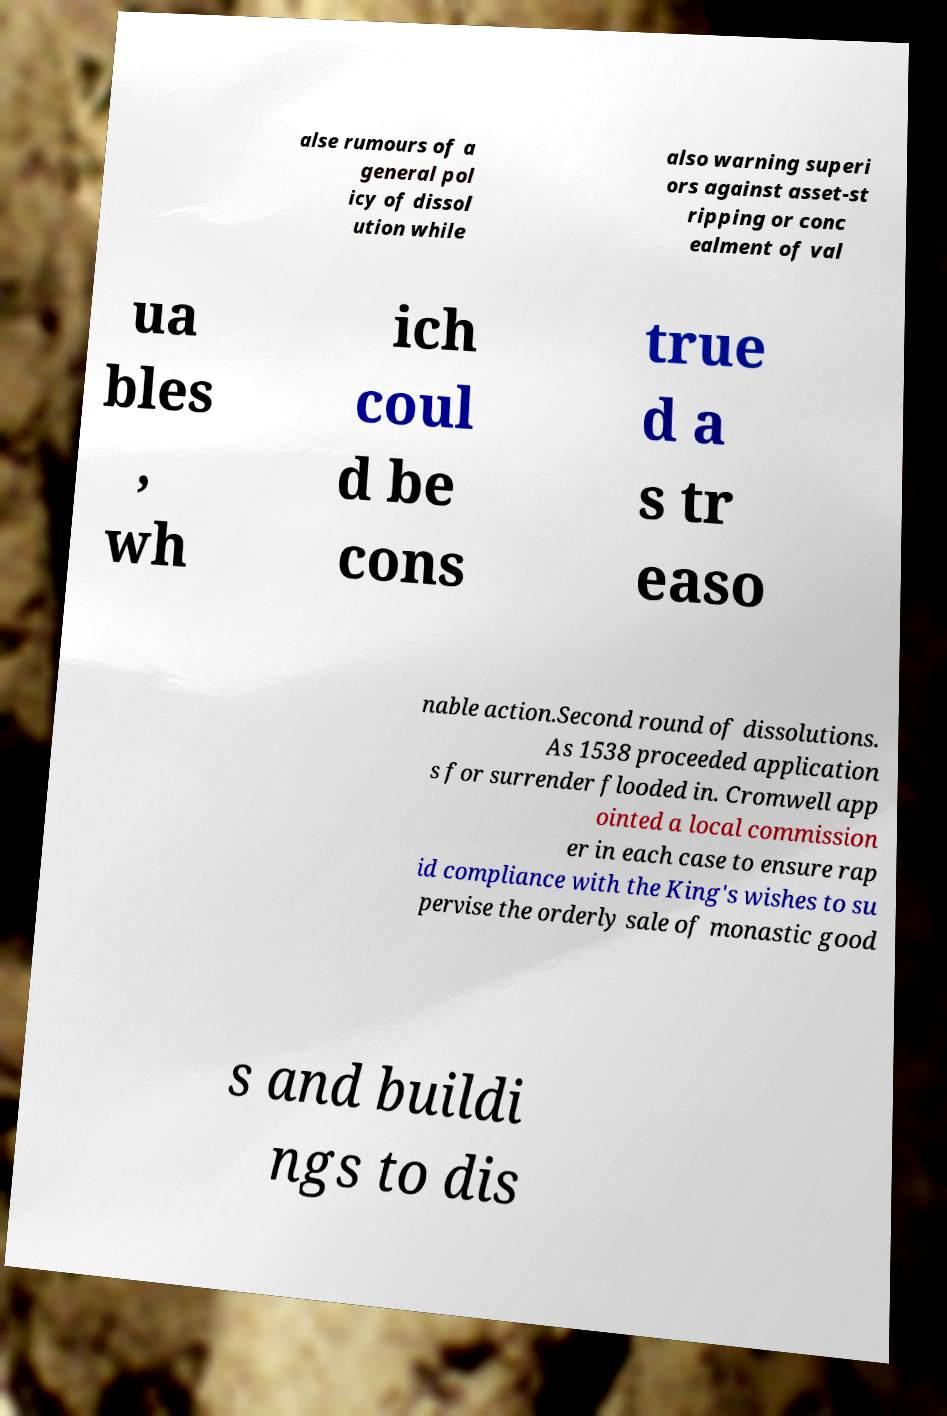Please identify and transcribe the text found in this image. alse rumours of a general pol icy of dissol ution while also warning superi ors against asset-st ripping or conc ealment of val ua bles , wh ich coul d be cons true d a s tr easo nable action.Second round of dissolutions. As 1538 proceeded application s for surrender flooded in. Cromwell app ointed a local commission er in each case to ensure rap id compliance with the King's wishes to su pervise the orderly sale of monastic good s and buildi ngs to dis 